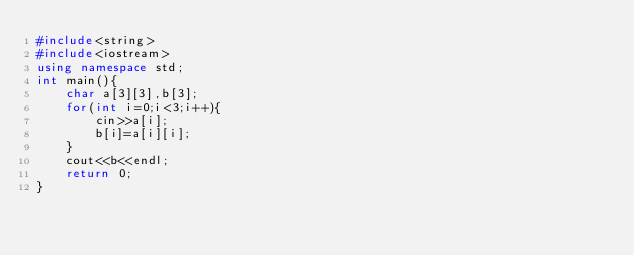Convert code to text. <code><loc_0><loc_0><loc_500><loc_500><_C++_>#include<string>
#include<iostream>
using namespace std;
int main(){
	char a[3][3],b[3];
	for(int i=0;i<3;i++){
		cin>>a[i];
		b[i]=a[i][i];
	}
	cout<<b<<endl;
	return 0;
}</code> 